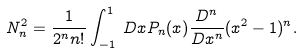Convert formula to latex. <formula><loc_0><loc_0><loc_500><loc_500>N _ { n } ^ { 2 } = \frac { 1 } { 2 ^ { n } n ! } \int _ { - 1 } ^ { 1 } \, D x P _ { n } ( x ) \frac { D ^ { n } } { D x ^ { n } } ( x ^ { 2 } - 1 ) ^ { n } .</formula> 